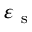<formula> <loc_0><loc_0><loc_500><loc_500>\varepsilon _ { s }</formula> 